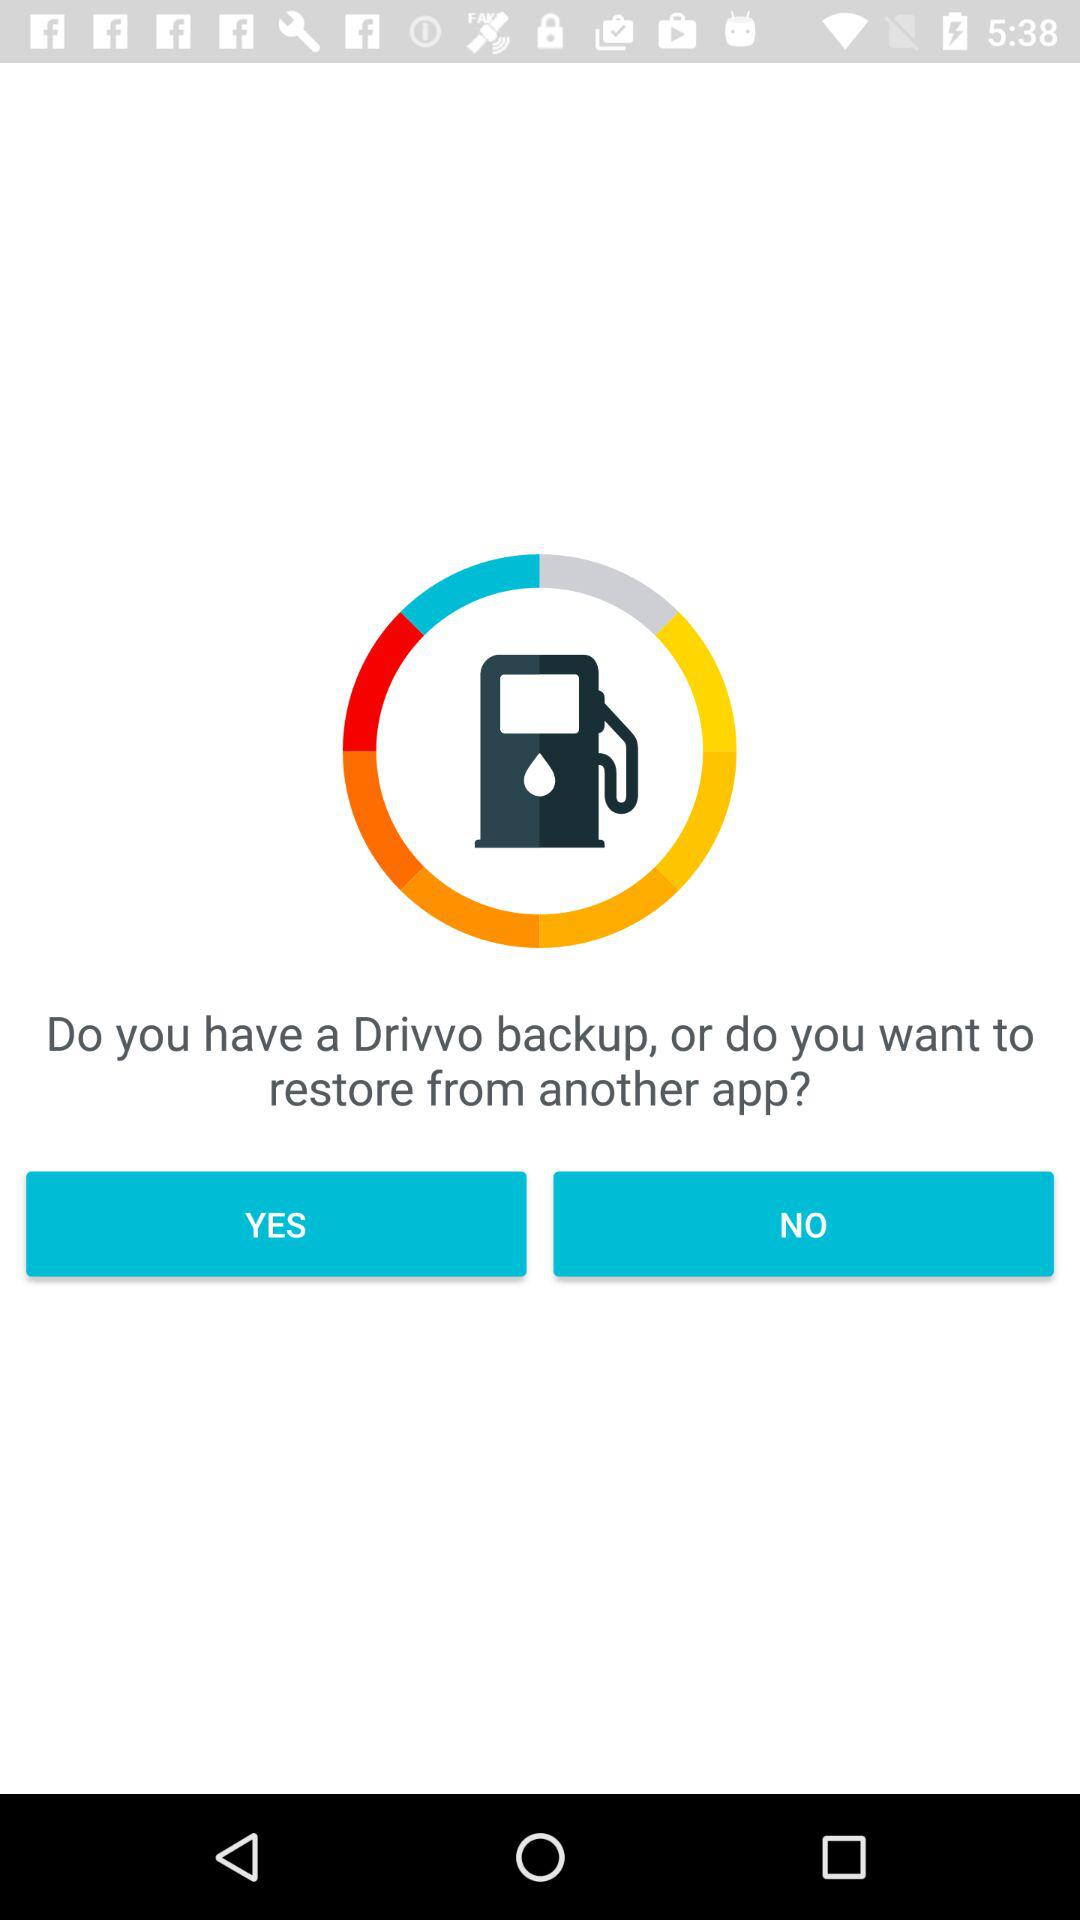Is "YES" selected?
When the provided information is insufficient, respond with <no answer>. <no answer> 